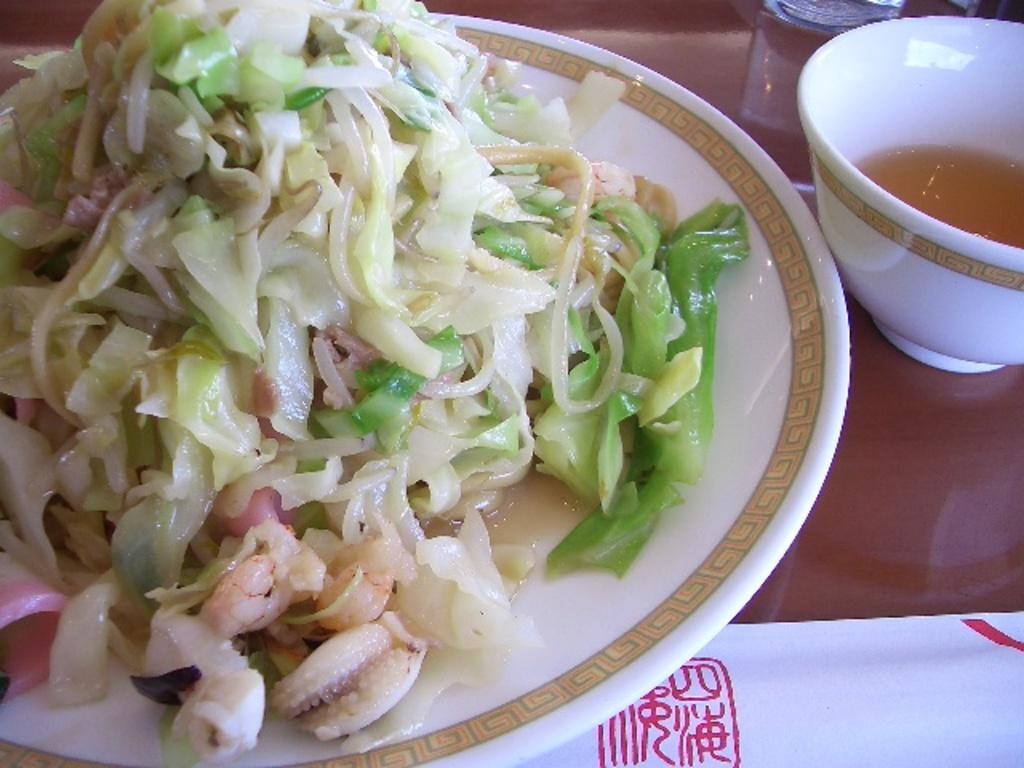How would you summarize this image in a sentence or two? There is an edible placed in the plate and there is a soup in the bowl placed beside it. 